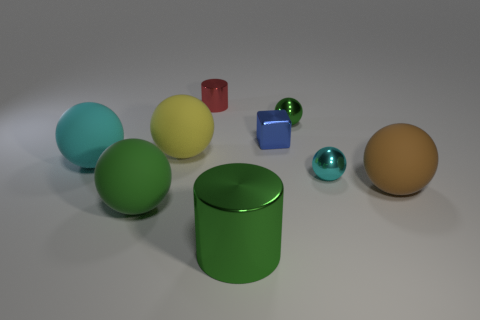Are there any cyan matte objects that are behind the big rubber sphere to the left of the green rubber object?
Your response must be concise. No. There is a green object that is the same shape as the tiny red metal object; what is it made of?
Provide a short and direct response. Metal. Is the number of small objects in front of the large cyan rubber ball greater than the number of cyan metallic objects to the left of the blue shiny thing?
Your answer should be compact. Yes. There is a blue thing that is the same material as the tiny cyan ball; what shape is it?
Offer a very short reply. Cube. Is the number of blue metallic blocks that are in front of the tiny green thing greater than the number of gray cylinders?
Offer a terse response. Yes. How many shiny cylinders are the same color as the metal block?
Make the answer very short. 0. How many other things are the same color as the tiny block?
Keep it short and to the point. 0. Is the number of yellow rubber things greater than the number of green spheres?
Keep it short and to the point. No. What is the material of the small block?
Ensure brevity in your answer.  Metal. Is the size of the green ball that is in front of the blue metal cube the same as the green metal cylinder?
Offer a terse response. Yes. 